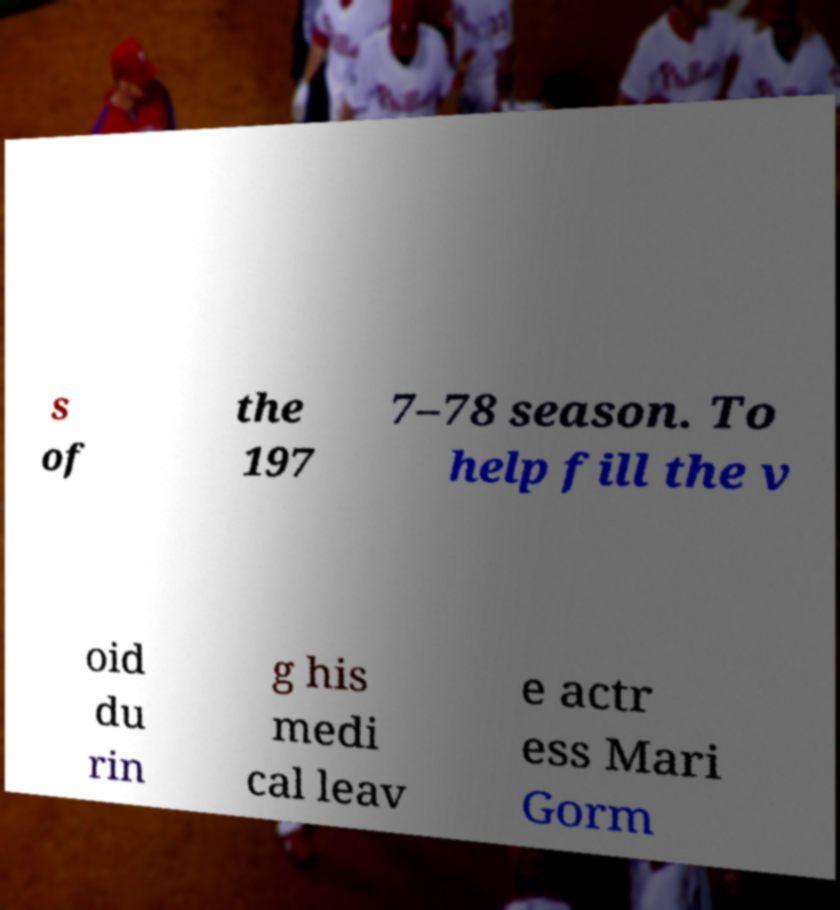Can you accurately transcribe the text from the provided image for me? s of the 197 7–78 season. To help fill the v oid du rin g his medi cal leav e actr ess Mari Gorm 